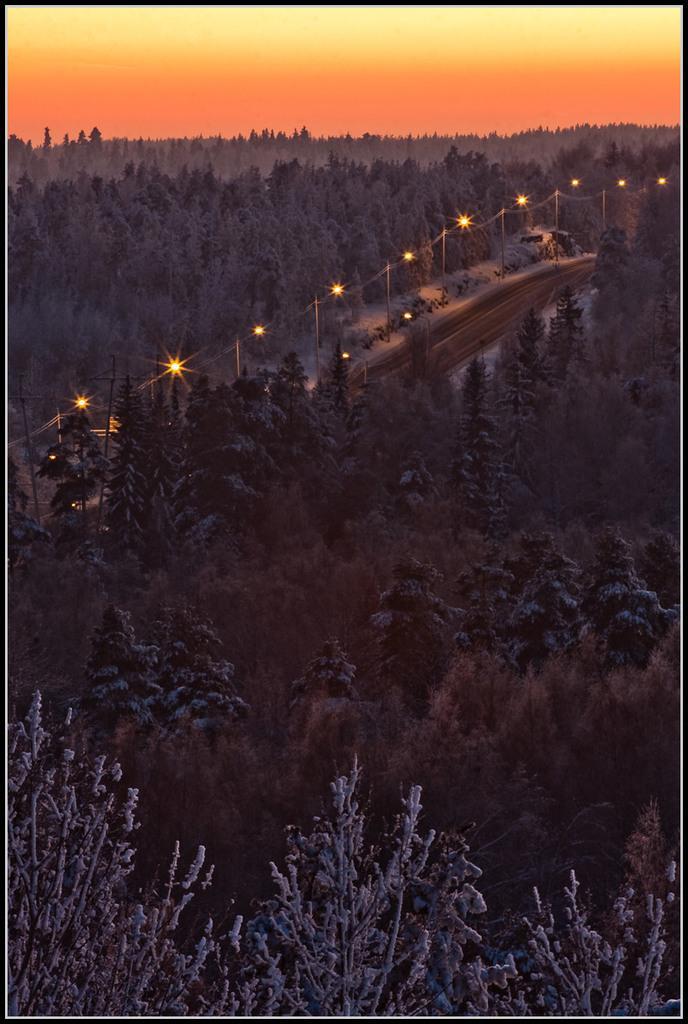Could you give a brief overview of what you see in this image? In this image we can see a large group of trees and a pathway with some street lights. On the backside we can see the sky. 